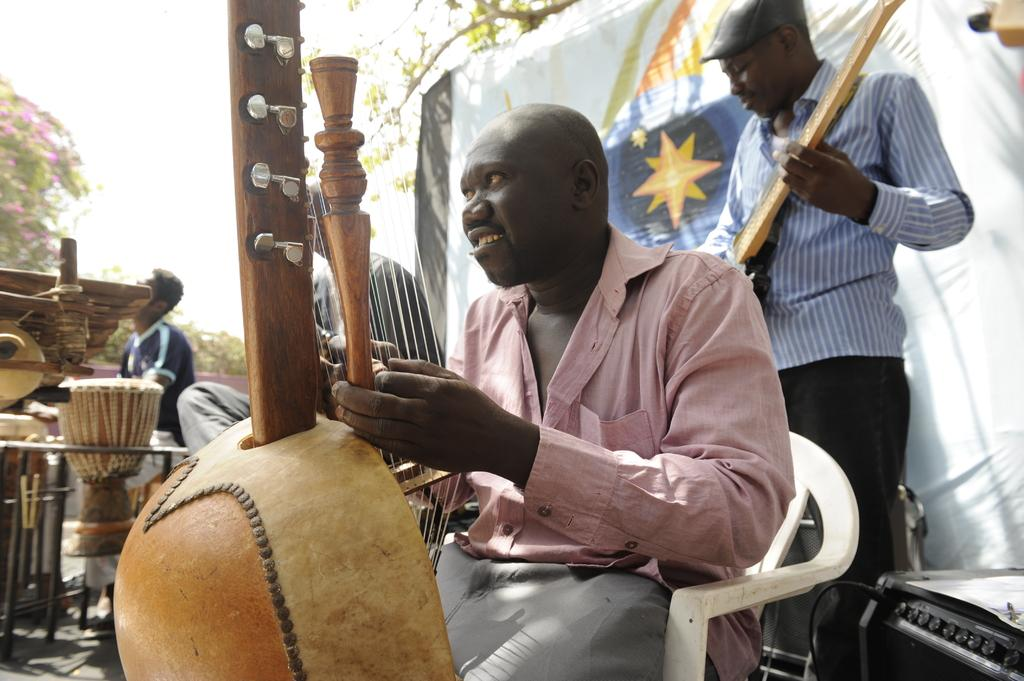What can be seen outside the room in the image? There are musical instruments outside the room in the image. How many people are present in the image? There are four persons in the image. What are the positions of the persons in the image? Two of the persons are sitting, and two of the persons are playing musical instruments. What type of thunder can be heard in the background of the image? There is no thunder present in the image; it is a scene of people playing musical instruments. Can you describe the route the persons took to reach the location in the image? The provided facts do not give any information about the persons' route to reach the location in the image. 